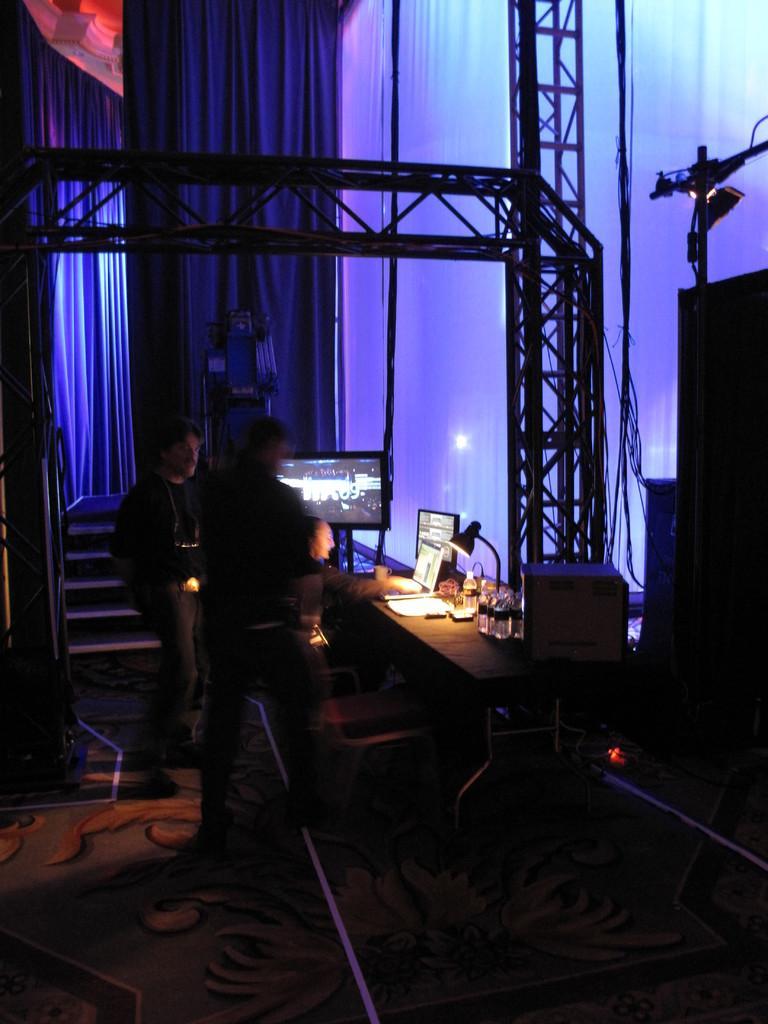In one or two sentences, can you explain what this image depicts? This picture is completely dark. We can see persons standing in front of a table and on the table we can see screens, table lamp , bottle. Here we can see stairs and a huge curtain. This is a floor. 